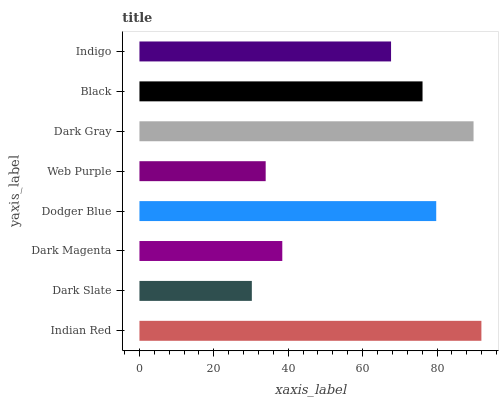Is Dark Slate the minimum?
Answer yes or no. Yes. Is Indian Red the maximum?
Answer yes or no. Yes. Is Dark Magenta the minimum?
Answer yes or no. No. Is Dark Magenta the maximum?
Answer yes or no. No. Is Dark Magenta greater than Dark Slate?
Answer yes or no. Yes. Is Dark Slate less than Dark Magenta?
Answer yes or no. Yes. Is Dark Slate greater than Dark Magenta?
Answer yes or no. No. Is Dark Magenta less than Dark Slate?
Answer yes or no. No. Is Black the high median?
Answer yes or no. Yes. Is Indigo the low median?
Answer yes or no. Yes. Is Indigo the high median?
Answer yes or no. No. Is Indian Red the low median?
Answer yes or no. No. 